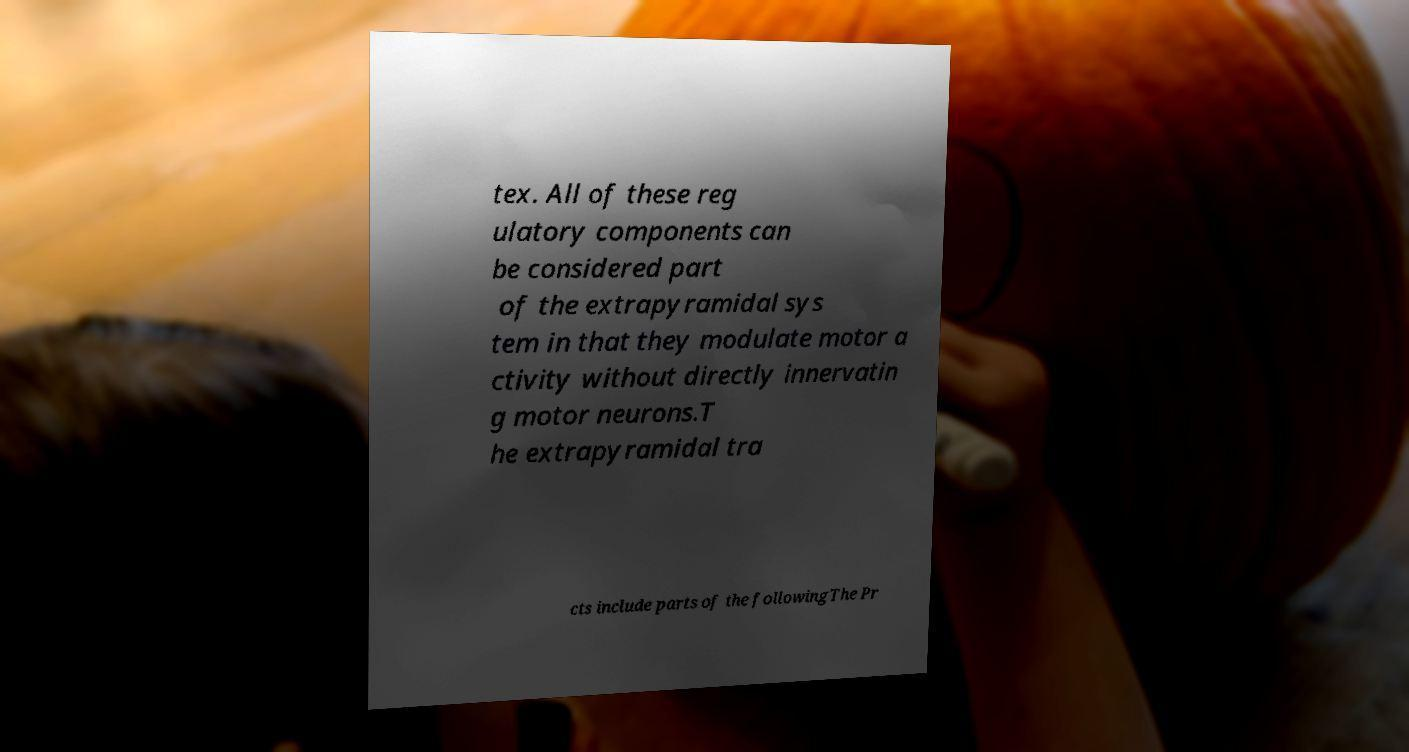For documentation purposes, I need the text within this image transcribed. Could you provide that? tex. All of these reg ulatory components can be considered part of the extrapyramidal sys tem in that they modulate motor a ctivity without directly innervatin g motor neurons.T he extrapyramidal tra cts include parts of the followingThe Pr 